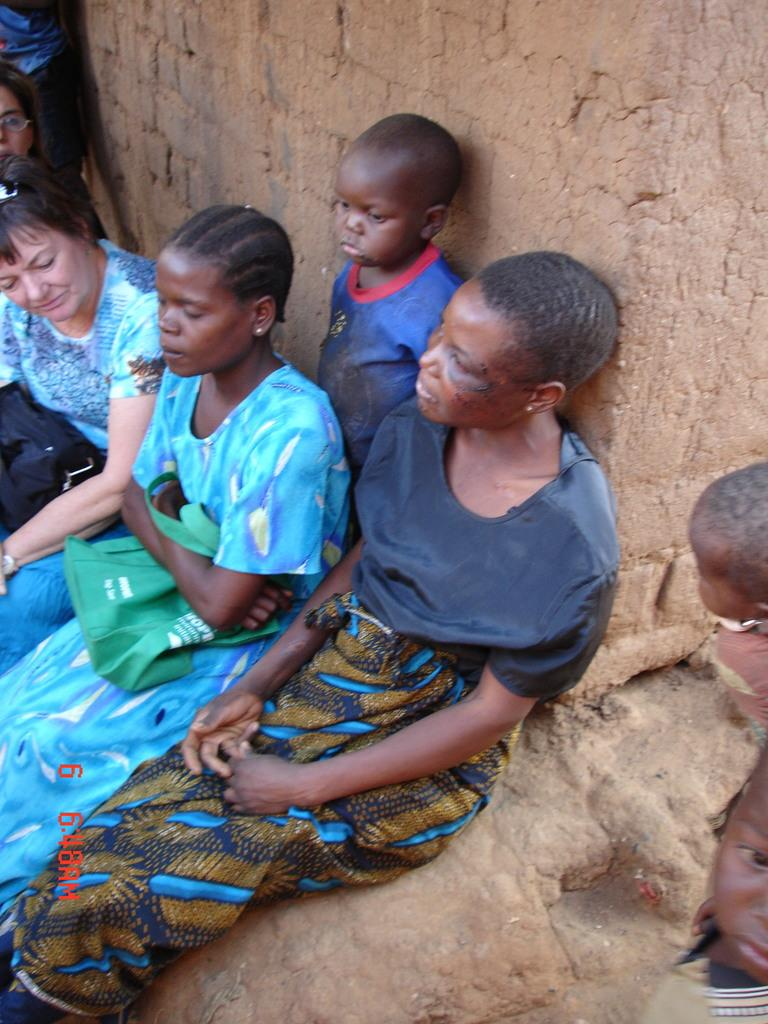Who is present in the image? There are women and children in the image. What are the women and children doing in the image? The women and children are standing or sitting on the ground. What type of zipper can be seen on the children's clothing in the image? There is no zipper visible on the children's clothing in the image. What season is depicted in the image? The provided facts do not mention any specific season, so it cannot be determined from the image. 